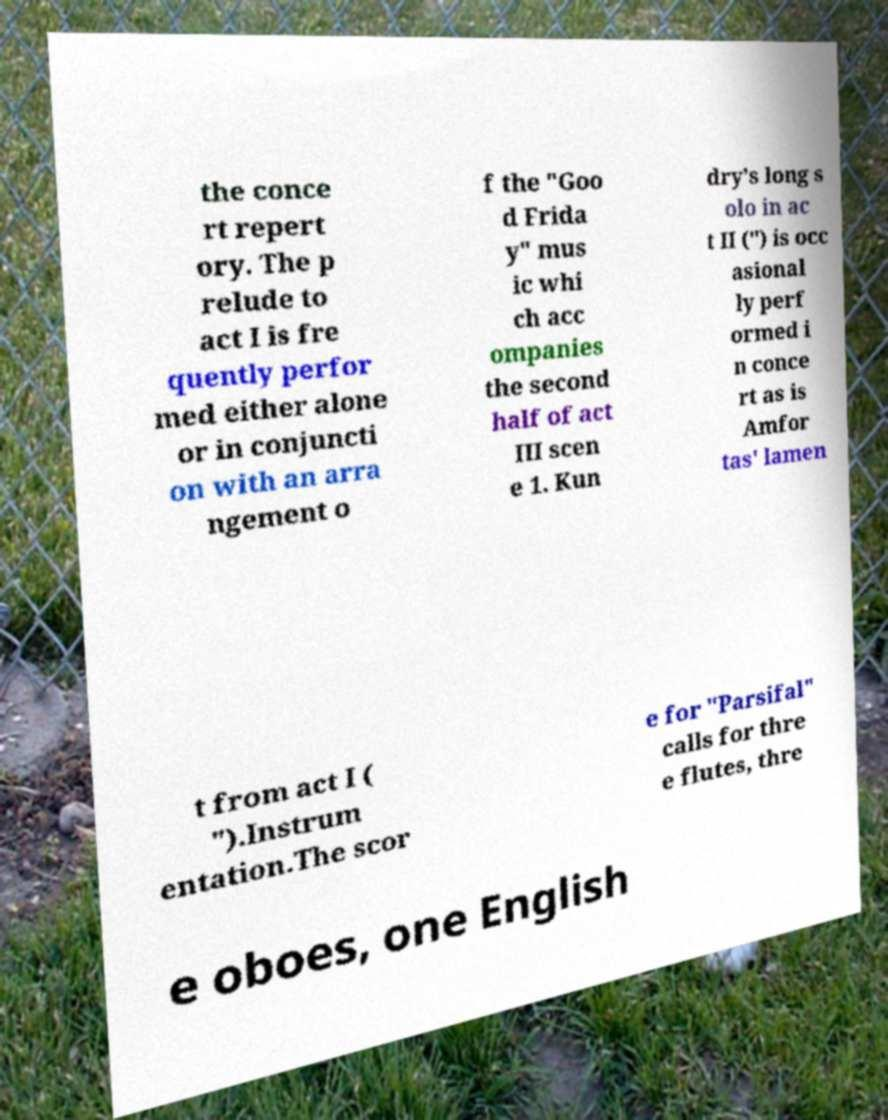What messages or text are displayed in this image? I need them in a readable, typed format. the conce rt repert ory. The p relude to act I is fre quently perfor med either alone or in conjuncti on with an arra ngement o f the "Goo d Frida y" mus ic whi ch acc ompanies the second half of act III scen e 1. Kun dry's long s olo in ac t II (") is occ asional ly perf ormed i n conce rt as is Amfor tas' lamen t from act I ( ").Instrum entation.The scor e for "Parsifal" calls for thre e flutes, thre e oboes, one English 